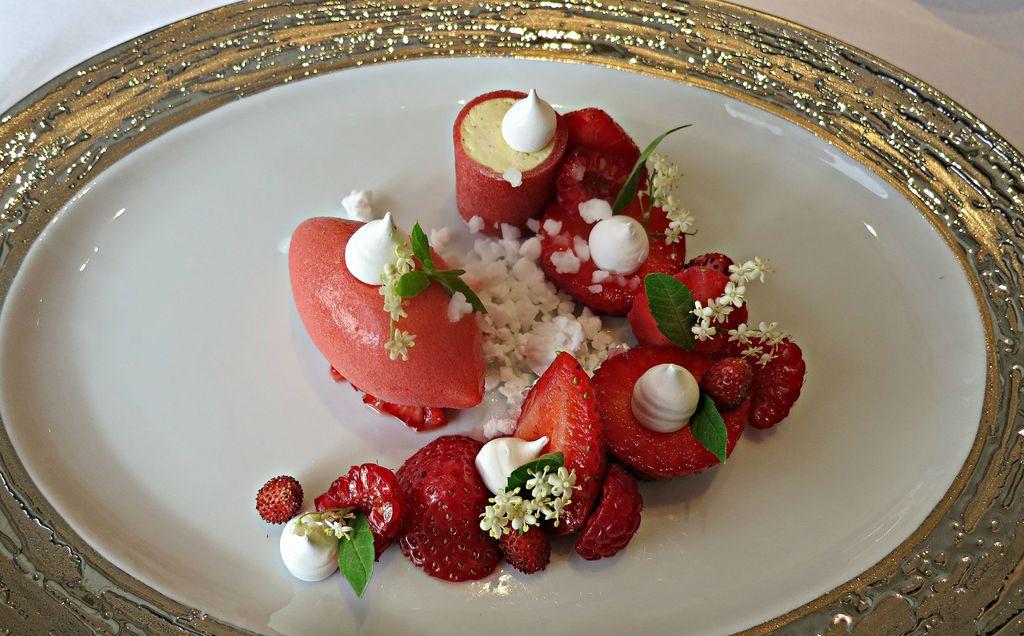How would you summarize this image in a sentence or two? In the center of the image there is a salad in plate placed on the table. 